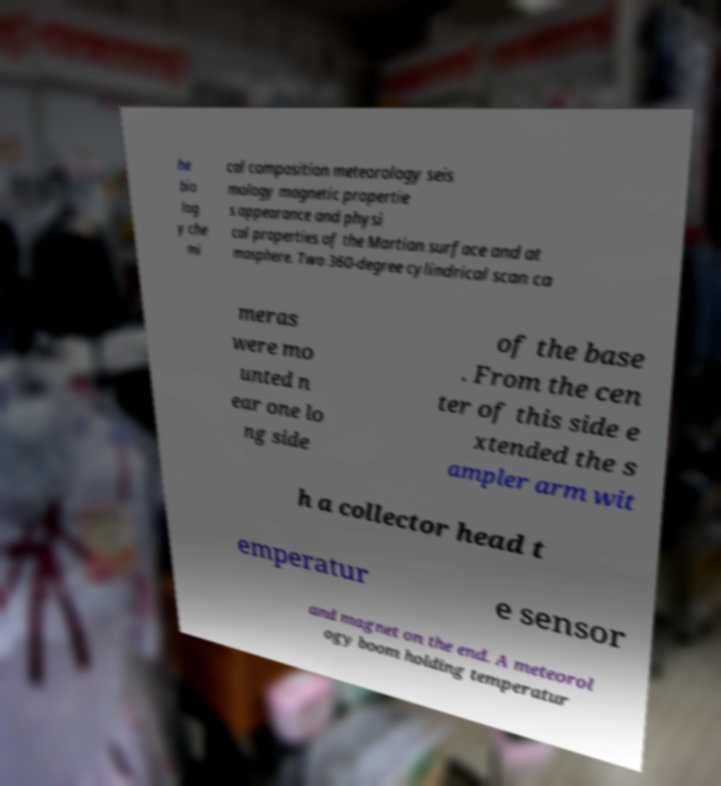Can you read and provide the text displayed in the image?This photo seems to have some interesting text. Can you extract and type it out for me? he bio log y che mi cal composition meteorology seis mology magnetic propertie s appearance and physi cal properties of the Martian surface and at mosphere. Two 360-degree cylindrical scan ca meras were mo unted n ear one lo ng side of the base . From the cen ter of this side e xtended the s ampler arm wit h a collector head t emperatur e sensor and magnet on the end. A meteorol ogy boom holding temperatur 